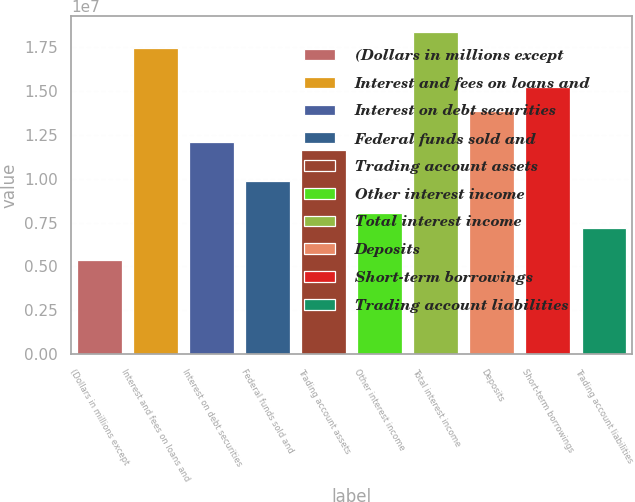Convert chart. <chart><loc_0><loc_0><loc_500><loc_500><bar_chart><fcel>(Dollars in millions except<fcel>Interest and fees on loans and<fcel>Interest on debt securities<fcel>Federal funds sold and<fcel>Trading account assets<fcel>Other interest income<fcel>Total interest income<fcel>Deposits<fcel>Short-term borrowings<fcel>Trading account liabilities<nl><fcel>5.3763e+06<fcel>1.7473e+07<fcel>1.20967e+07<fcel>9.85656e+06<fcel>1.16487e+07<fcel>8.06446e+06<fcel>1.8369e+07<fcel>1.38888e+07<fcel>1.52329e+07<fcel>7.1684e+06<nl></chart> 